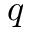<formula> <loc_0><loc_0><loc_500><loc_500>q</formula> 